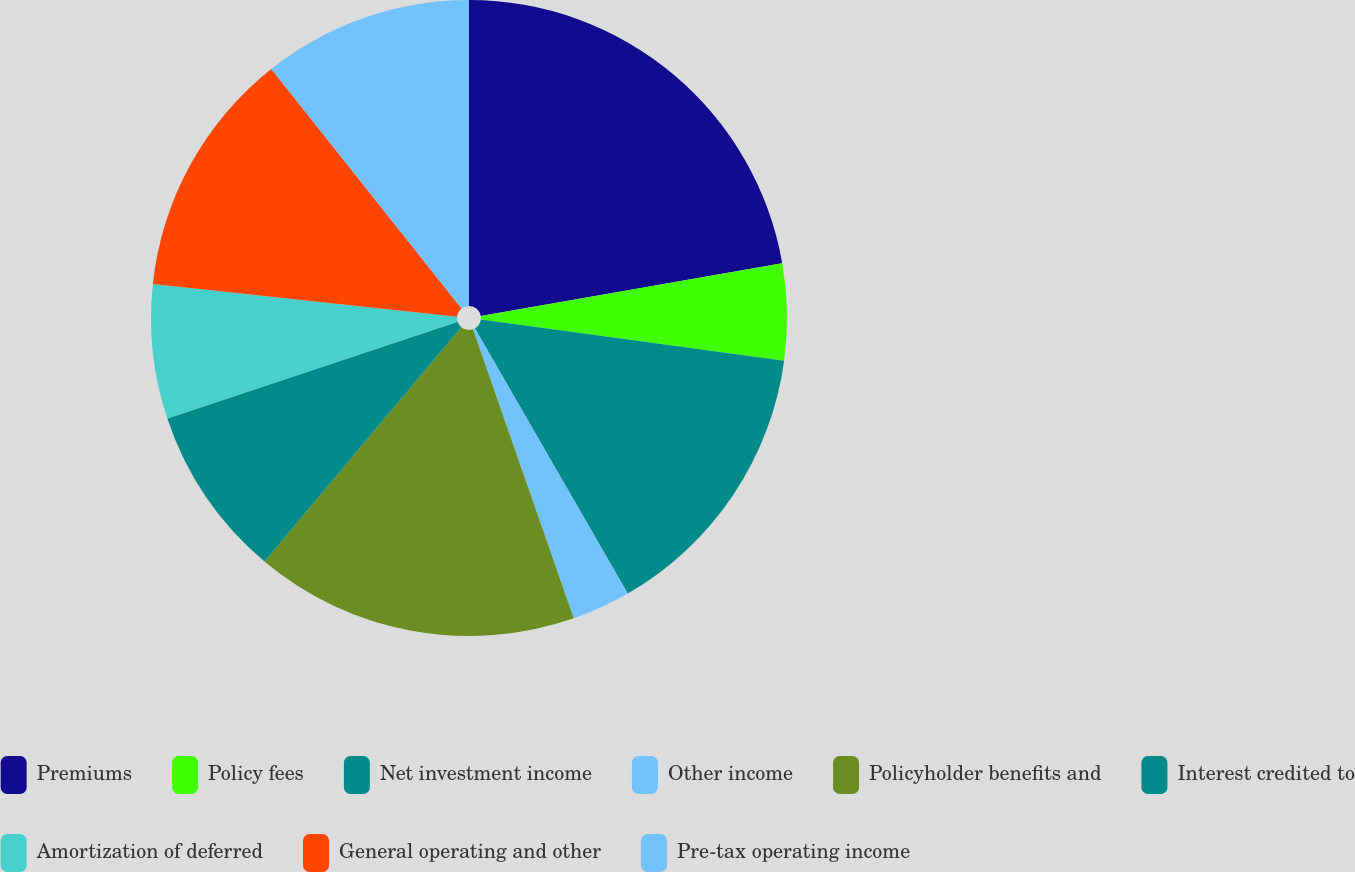<chart> <loc_0><loc_0><loc_500><loc_500><pie_chart><fcel>Premiums<fcel>Policy fees<fcel>Net investment income<fcel>Other income<fcel>Policyholder benefits and<fcel>Interest credited to<fcel>Amortization of deferred<fcel>General operating and other<fcel>Pre-tax operating income<nl><fcel>22.24%<fcel>4.9%<fcel>14.54%<fcel>2.98%<fcel>16.46%<fcel>8.76%<fcel>6.83%<fcel>12.61%<fcel>10.68%<nl></chart> 